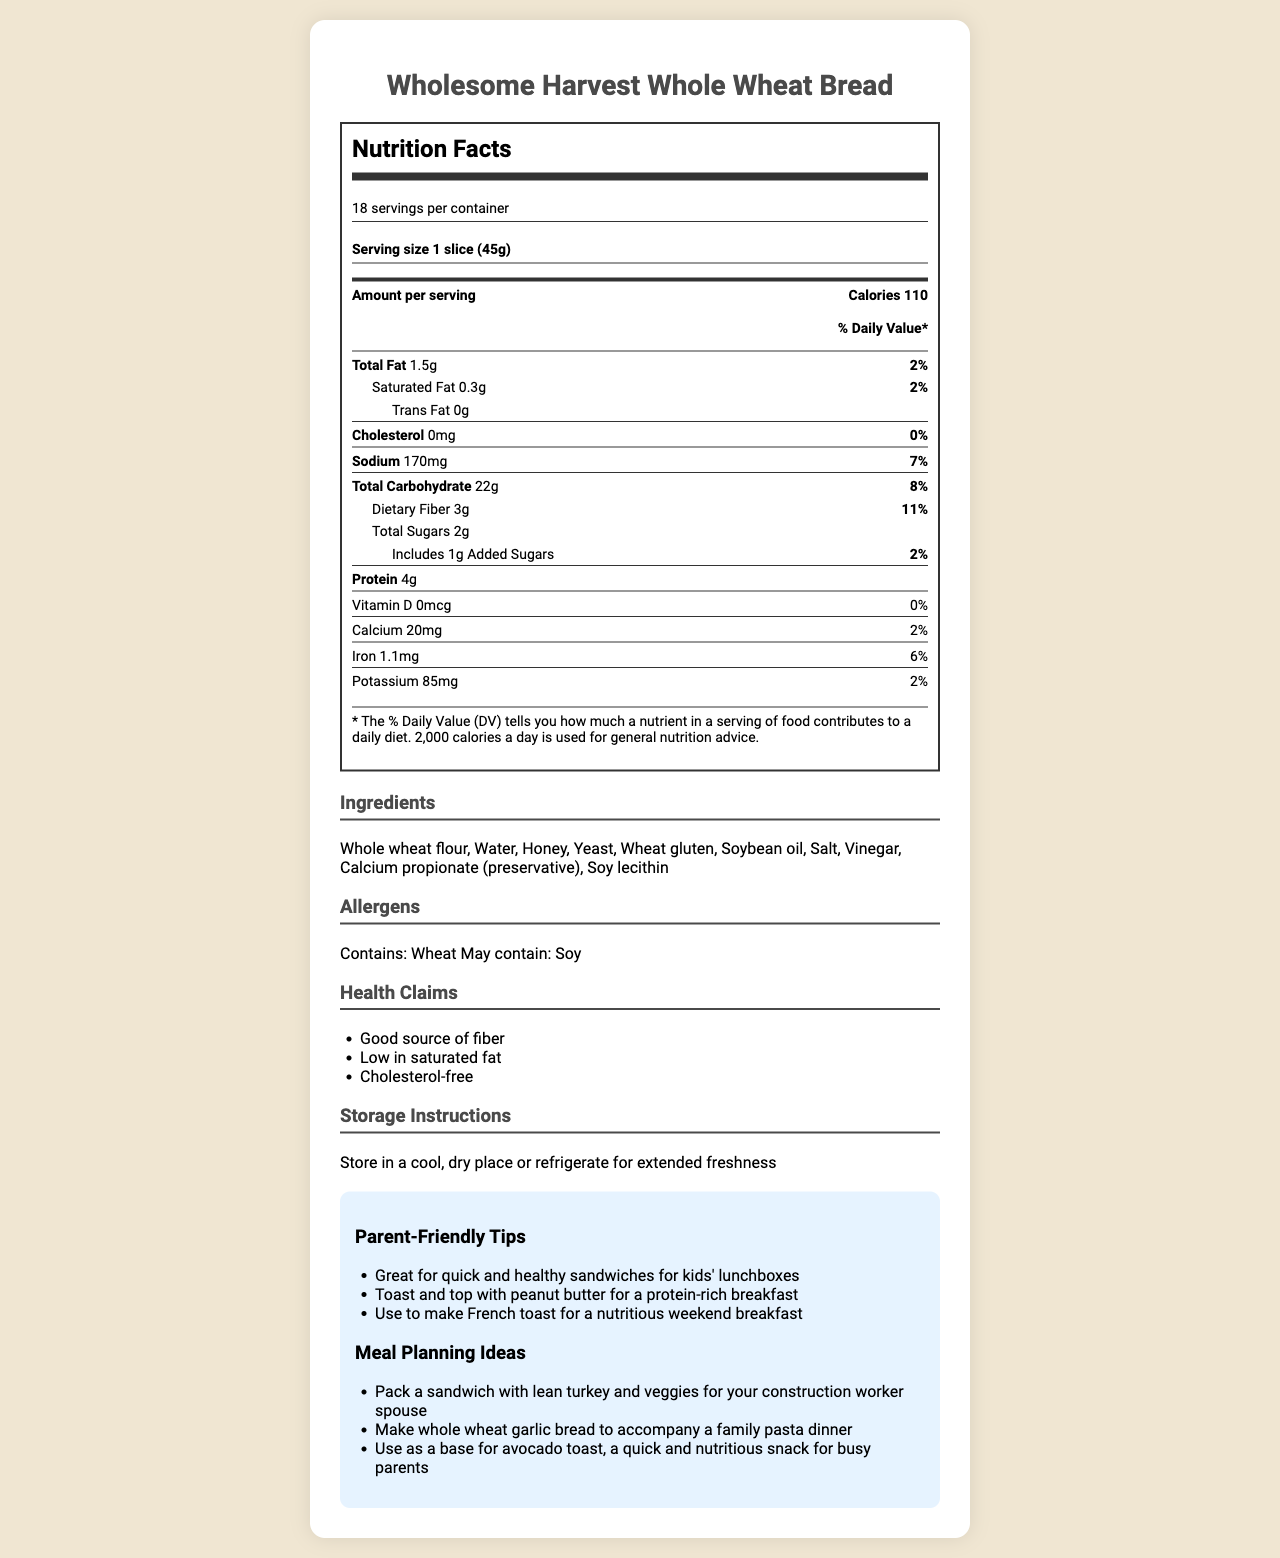what is the serving size of the bread? The serving size is listed as "1 slice (45g)" right below the product name.
Answer: 1 slice (45g) how many grams of total carbohydrates are present per serving? The document states "Total Carbohydrate 22g" under the nutrient information.
Answer: 22g what percentage of the daily value does the dietary fiber contribute? It shows "Dietary Fiber 3g" contributing to "11% Daily Value" in the nutrient section.
Answer: 11% which vitamins and minerals are present in the bread? The nutrients are listed under the respective amounts and daily values in the nutrient section, including Vitamin D, Calcium, Iron, Potassium, Thiamin, Riboflavin, Niacin, and Folate.
Answer: Vitamin D, Calcium, Iron, Potassium, Thiamin, Riboflavin, Niacin, Folate how many calories are there in two slices of bread? Since each slice contains 110 calories, two slices would contain 110 x 2 = 220 calories.
Answer: 220 calories which ingredient is used as a preservative in the bread? A. Honey B. Calcium propionate C. Soy lecithin The list of ingredients includes "Calcium propionate (preservative)", so option B is correct.
Answer: B how should the bread be stored to maintain freshness? The storage instructions mention to "Store in a cool, dry place or refrigerate for extended freshness."
Answer: Store in a cool, dry place or refrigerate does this bread contain any allergens? The document lists "Contains: Wheat, May contain: Soy" under allergens.
Answer: Yes which nutrient has the highest daily value percentage? A. Total Fat B. Sodium C. Thiamin D. Dietary Fiber Thiamin has the highest daily value percentage at 15%, followed by dietary fiber (11%), total carbohydrate (8%), and sodium (7%).
Answer: C is the bread a good source of fiber? The health claims section states "Good source of fiber," affirming that the bread is a good source of fiber.
Answer: Yes can we determine the exact amount of complex carbohydrates contributing to the daily value? The document mentions "complex carbohydrates: 17g," but there is "N/A" for the daily value percentage, making it undetermined.
Answer: No summarize the main idea of the document It details the bread's nutritional profile, ingredients, allergens, and includes several user-friendly tips and health suggestions for better understanding and usage.
Answer: The document provides comprehensive nutritional information about Wholesome Harvest Whole Wheat Bread including serving size, calories, macronutrient content, and micronutrient details, along with ingredients, allergens, health claims, storage instructions, and tips for parents and meal planning. what are some meal planning ideas suggested in the document? The document lists three specific meal planning ideas in the parent-friendly tips and meal planning section.
Answer: Pack a sandwich with lean turkey and veggies, make whole wheat garlic bread, and use as a base for avocado toast 